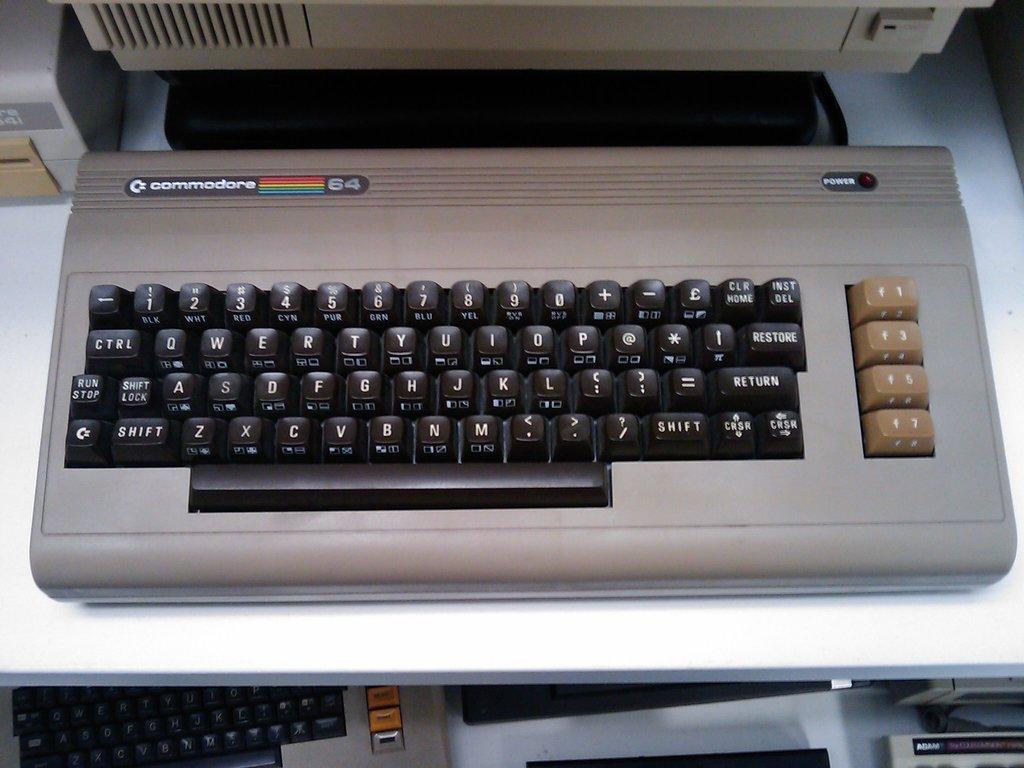Please provide a concise description of this image. In this image in the front there are keyboards and at the top of the image there are objects which are white in colour and black in colour. 